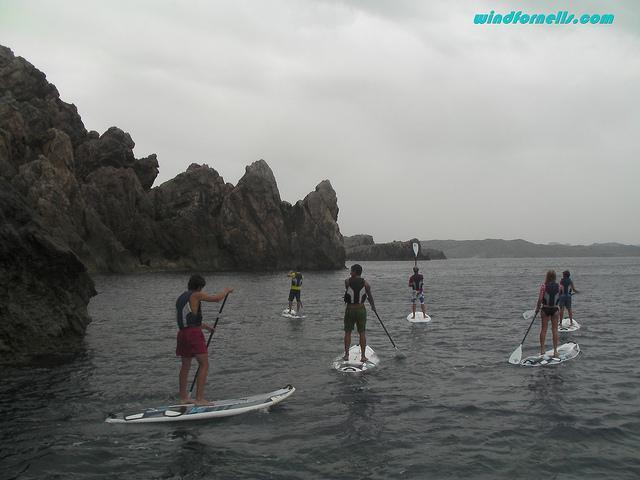How many people are surfing?
Give a very brief answer. 6. 